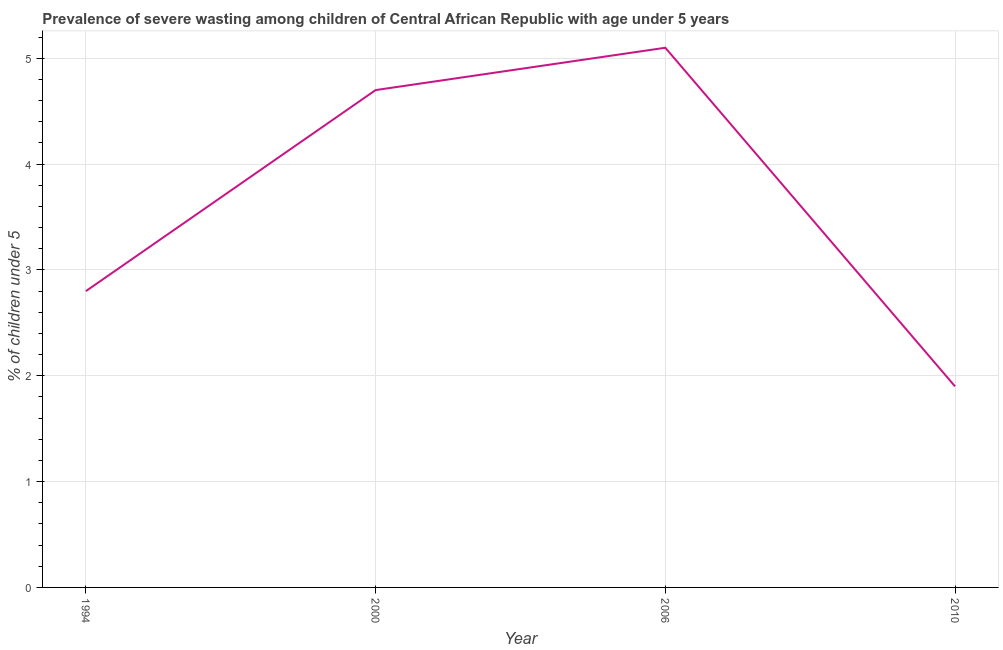What is the prevalence of severe wasting in 2010?
Give a very brief answer. 1.9. Across all years, what is the maximum prevalence of severe wasting?
Offer a very short reply. 5.1. Across all years, what is the minimum prevalence of severe wasting?
Offer a terse response. 1.9. In which year was the prevalence of severe wasting minimum?
Provide a short and direct response. 2010. What is the sum of the prevalence of severe wasting?
Provide a succinct answer. 14.5. What is the difference between the prevalence of severe wasting in 2000 and 2006?
Offer a terse response. -0.4. What is the average prevalence of severe wasting per year?
Offer a very short reply. 3.62. What is the median prevalence of severe wasting?
Your response must be concise. 3.75. Do a majority of the years between 2006 and 2000 (inclusive) have prevalence of severe wasting greater than 2.2 %?
Your response must be concise. No. What is the ratio of the prevalence of severe wasting in 2006 to that in 2010?
Your answer should be compact. 2.68. Is the prevalence of severe wasting in 1994 less than that in 2010?
Keep it short and to the point. No. Is the difference between the prevalence of severe wasting in 1994 and 2006 greater than the difference between any two years?
Offer a terse response. No. What is the difference between the highest and the second highest prevalence of severe wasting?
Ensure brevity in your answer.  0.4. What is the difference between the highest and the lowest prevalence of severe wasting?
Your response must be concise. 3.2. In how many years, is the prevalence of severe wasting greater than the average prevalence of severe wasting taken over all years?
Offer a very short reply. 2. Does the prevalence of severe wasting monotonically increase over the years?
Provide a succinct answer. No. Does the graph contain grids?
Offer a terse response. Yes. What is the title of the graph?
Make the answer very short. Prevalence of severe wasting among children of Central African Republic with age under 5 years. What is the label or title of the X-axis?
Offer a very short reply. Year. What is the label or title of the Y-axis?
Make the answer very short.  % of children under 5. What is the  % of children under 5 in 1994?
Your response must be concise. 2.8. What is the  % of children under 5 in 2000?
Your answer should be compact. 4.7. What is the  % of children under 5 of 2006?
Offer a very short reply. 5.1. What is the  % of children under 5 in 2010?
Offer a terse response. 1.9. What is the difference between the  % of children under 5 in 1994 and 2006?
Make the answer very short. -2.3. What is the difference between the  % of children under 5 in 2006 and 2010?
Offer a terse response. 3.2. What is the ratio of the  % of children under 5 in 1994 to that in 2000?
Keep it short and to the point. 0.6. What is the ratio of the  % of children under 5 in 1994 to that in 2006?
Make the answer very short. 0.55. What is the ratio of the  % of children under 5 in 1994 to that in 2010?
Your answer should be compact. 1.47. What is the ratio of the  % of children under 5 in 2000 to that in 2006?
Ensure brevity in your answer.  0.92. What is the ratio of the  % of children under 5 in 2000 to that in 2010?
Provide a succinct answer. 2.47. What is the ratio of the  % of children under 5 in 2006 to that in 2010?
Your answer should be compact. 2.68. 